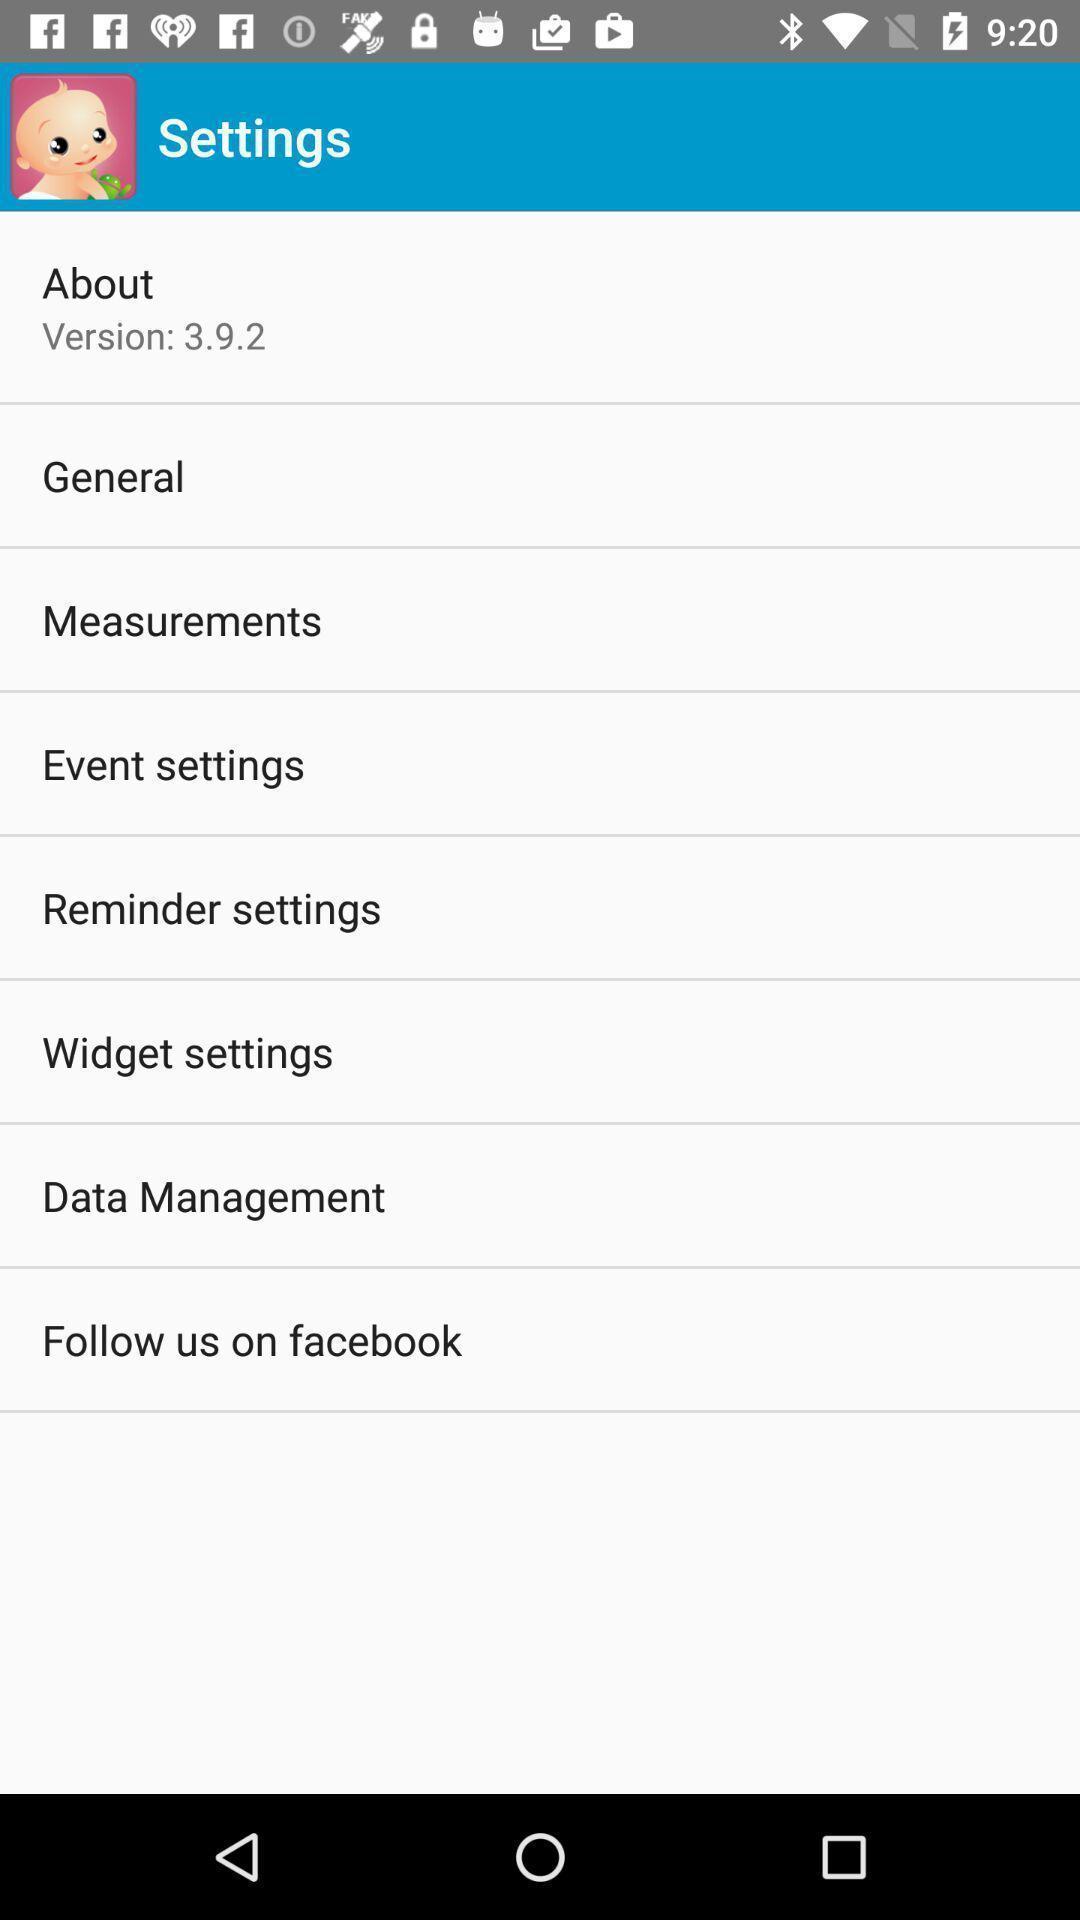Describe this image in words. Screen displaying the settings page. 